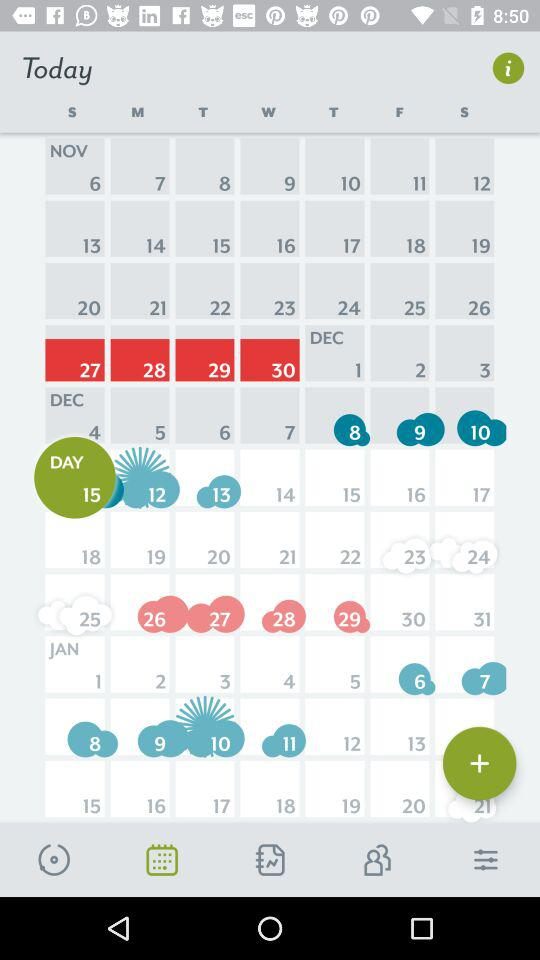Which are the selected dates? The selected dates are Sunday, November 27, Monday, November 28, Tuesday, November 29 and Wednesday, November 30. 